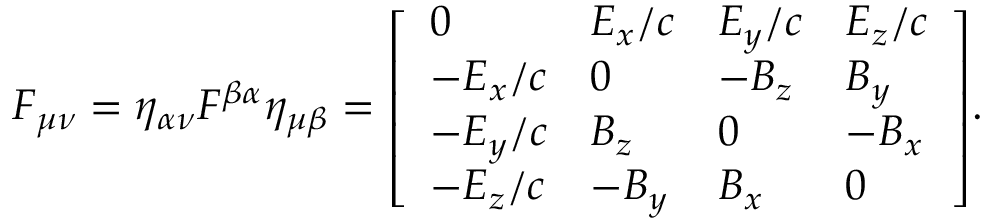Convert formula to latex. <formula><loc_0><loc_0><loc_500><loc_500>F _ { \mu \nu } = \eta _ { \alpha \nu } F ^ { \beta \alpha } \eta _ { \mu \beta } = { \left [ \begin{array} { l l l l } { 0 } & { E _ { x } / c } & { E _ { y } / c } & { E _ { z } / c } \\ { - E _ { x } / c } & { 0 } & { - B _ { z } } & { B _ { y } } \\ { - E _ { y } / c } & { B _ { z } } & { 0 } & { - B _ { x } } \\ { - E _ { z } / c } & { - B _ { y } } & { B _ { x } } & { 0 } \end{array} \right ] } .</formula> 